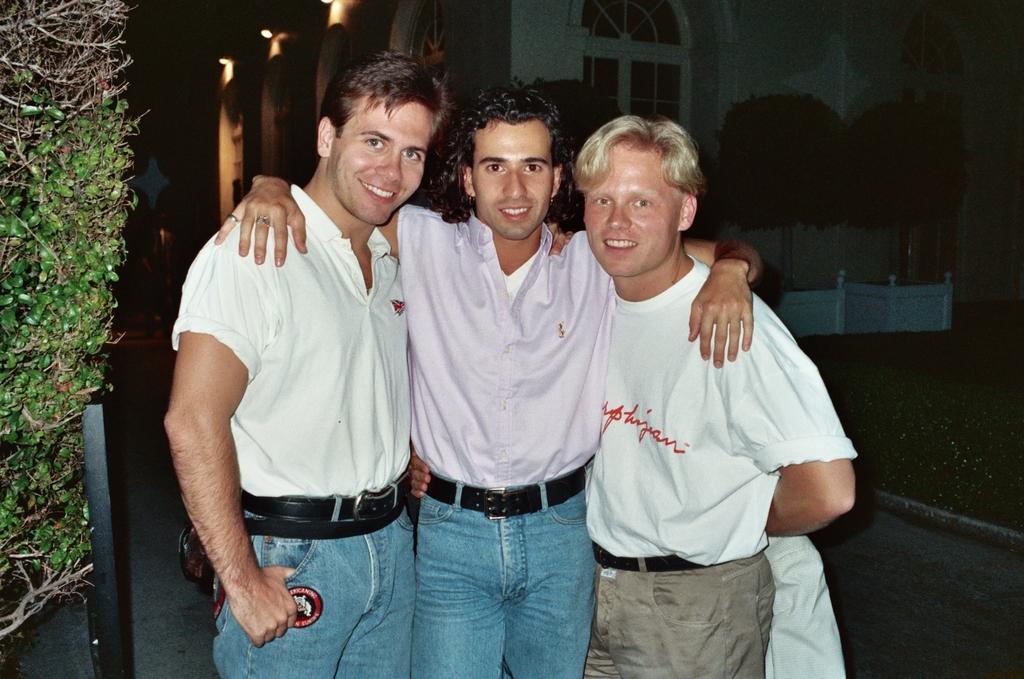Describe this image in one or two sentences. In the center of the image there are men standing on the floor. On the left side of the image there is a tree and a pole. In the background there is a building and trees. 